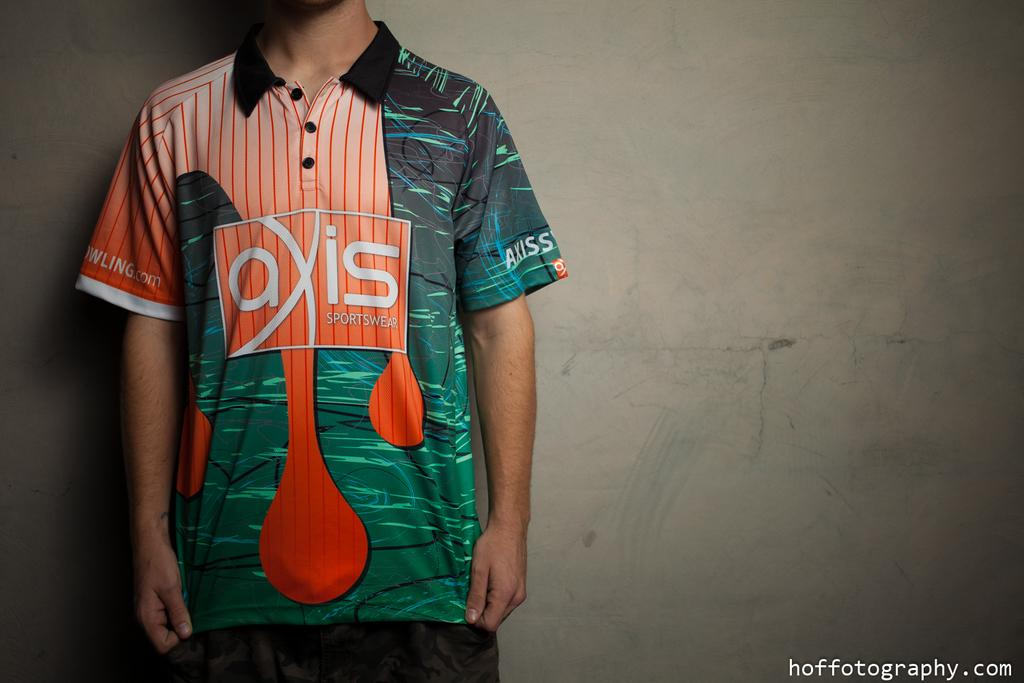<image>
Create a compact narrative representing the image presented. a shirt that has the word axis on it 